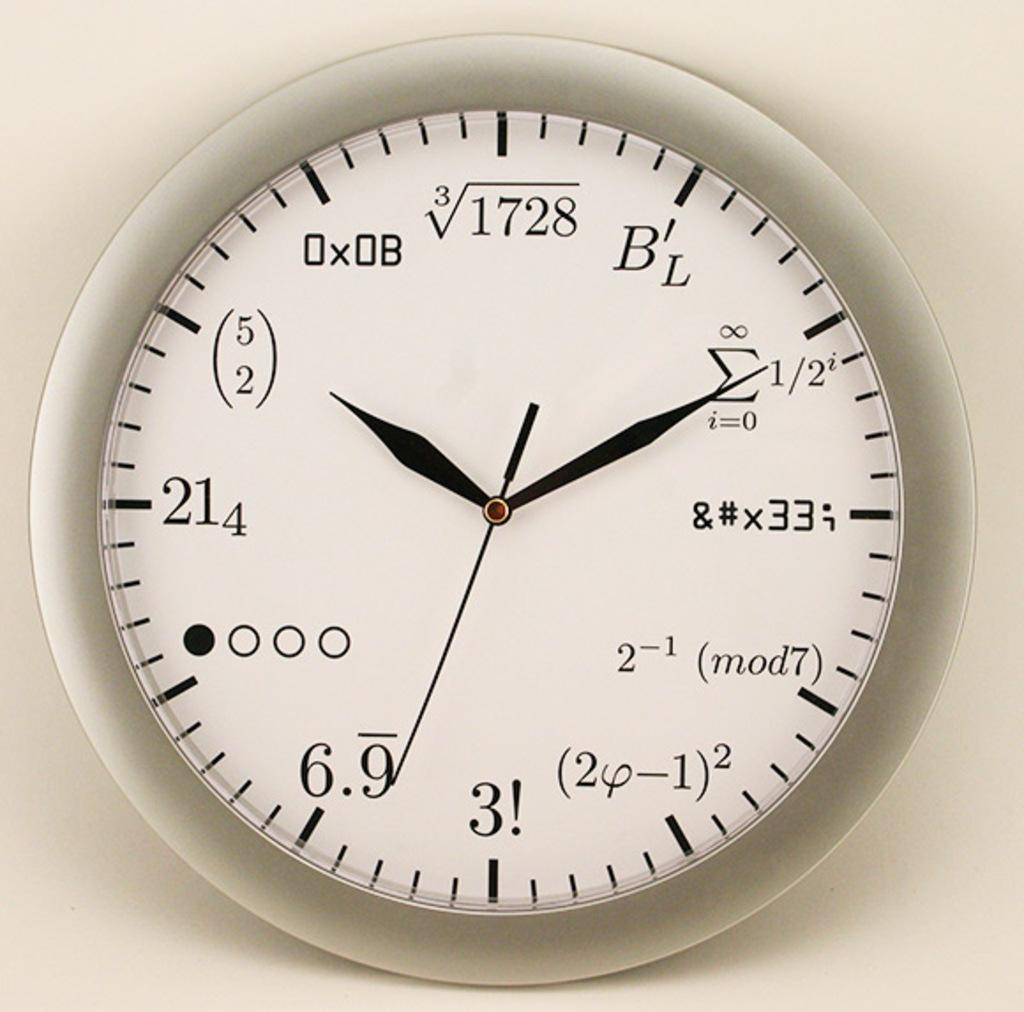<image>
Relay a brief, clear account of the picture shown. White, black, and silver clock with numbers and equations wrote on it 